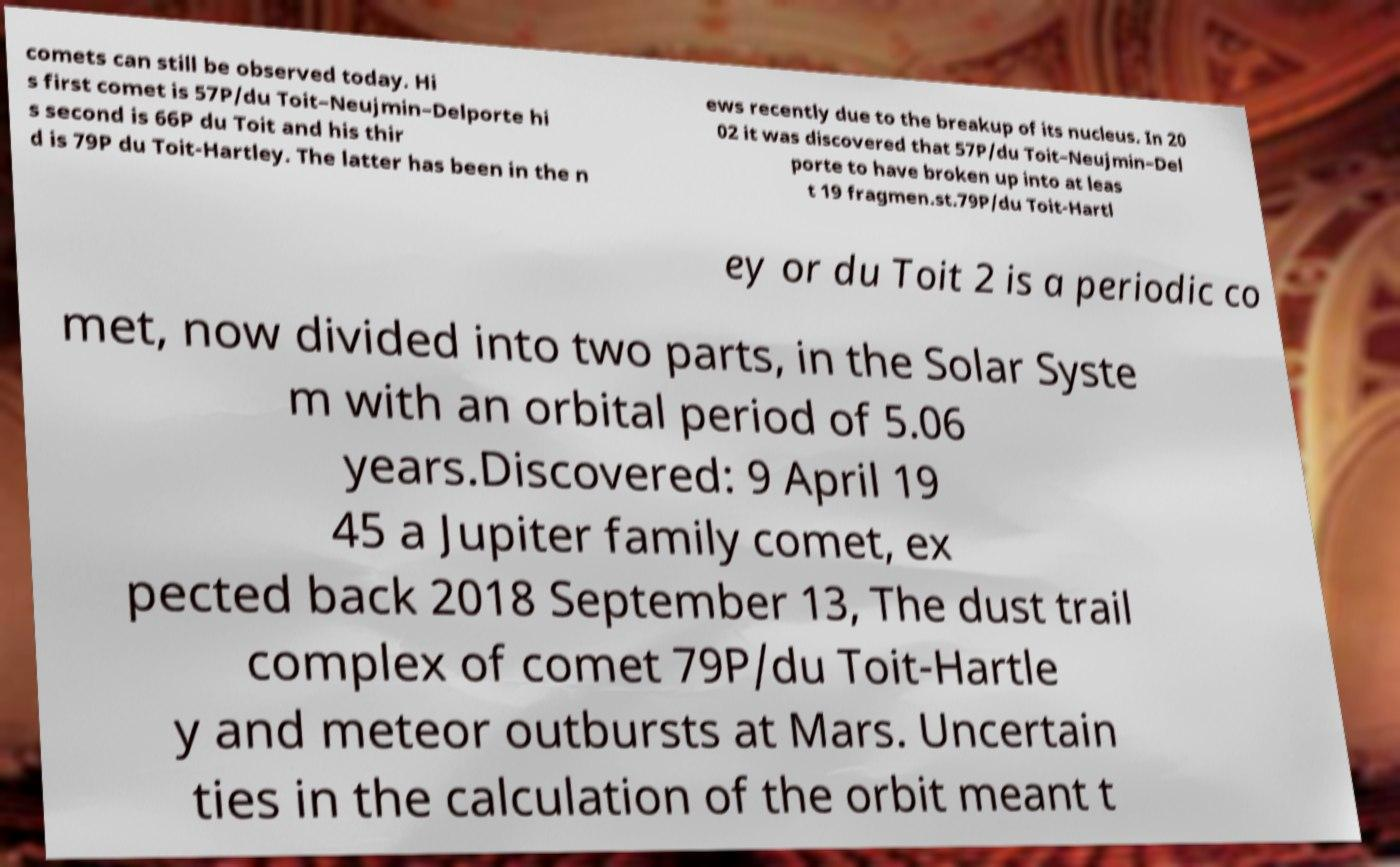Can you accurately transcribe the text from the provided image for me? comets can still be observed today. Hi s first comet is 57P/du Toit–Neujmin–Delporte hi s second is 66P du Toit and his thir d is 79P du Toit-Hartley. The latter has been in the n ews recently due to the breakup of its nucleus. In 20 02 it was discovered that 57P/du Toit–Neujmin–Del porte to have broken up into at leas t 19 fragmen.st.79P/du Toit-Hartl ey or du Toit 2 is a periodic co met, now divided into two parts, in the Solar Syste m with an orbital period of 5.06 years.Discovered: 9 April 19 45 a Jupiter family comet, ex pected back 2018 September 13, The dust trail complex of comet 79P/du Toit-Hartle y and meteor outbursts at Mars. Uncertain ties in the calculation of the orbit meant t 